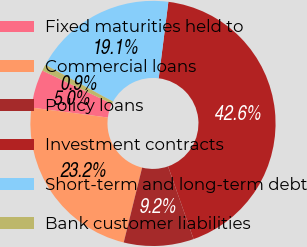Convert chart. <chart><loc_0><loc_0><loc_500><loc_500><pie_chart><fcel>Fixed maturities held to<fcel>Commercial loans<fcel>Policy loans<fcel>Investment contracts<fcel>Short-term and long-term debt<fcel>Bank customer liabilities<nl><fcel>5.03%<fcel>23.23%<fcel>9.21%<fcel>42.62%<fcel>19.06%<fcel>0.85%<nl></chart> 